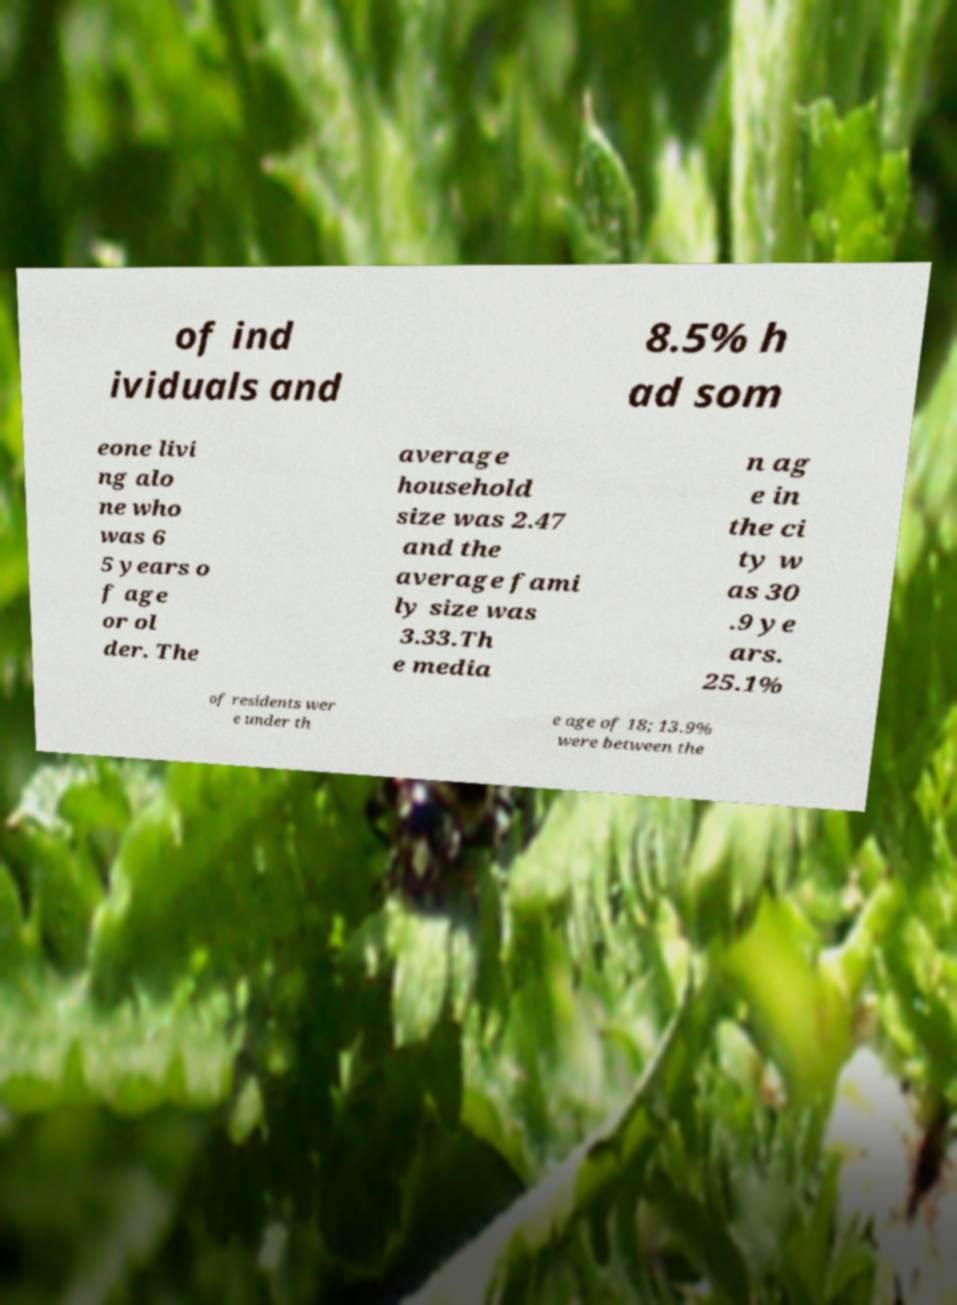There's text embedded in this image that I need extracted. Can you transcribe it verbatim? of ind ividuals and 8.5% h ad som eone livi ng alo ne who was 6 5 years o f age or ol der. The average household size was 2.47 and the average fami ly size was 3.33.Th e media n ag e in the ci ty w as 30 .9 ye ars. 25.1% of residents wer e under th e age of 18; 13.9% were between the 